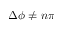<formula> <loc_0><loc_0><loc_500><loc_500>\Delta \phi \neq n \pi</formula> 